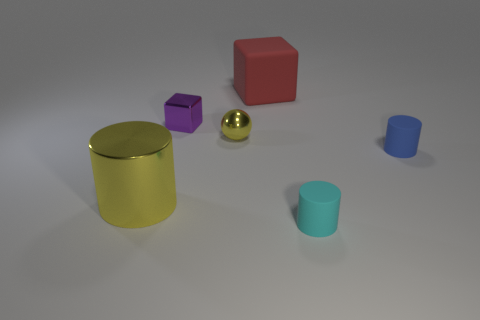Do the tiny yellow thing and the matte thing that is behind the blue rubber cylinder have the same shape?
Make the answer very short. No. How many things are both behind the shiny sphere and on the right side of the yellow ball?
Make the answer very short. 1. There is a yellow thing that is the same shape as the cyan rubber thing; what is it made of?
Give a very brief answer. Metal. There is a rubber cylinder in front of the tiny matte thing right of the cyan matte cylinder; what is its size?
Keep it short and to the point. Small. Are any tiny red cylinders visible?
Offer a terse response. No. What material is the small thing that is behind the cyan rubber cylinder and on the right side of the yellow sphere?
Offer a very short reply. Rubber. Is the number of small blue rubber objects on the left side of the small block greater than the number of big cubes on the left side of the red rubber object?
Your answer should be compact. No. Are there any blue matte objects of the same size as the red thing?
Provide a succinct answer. No. There is a yellow metallic object in front of the matte cylinder behind the tiny cylinder that is on the left side of the tiny blue thing; how big is it?
Your response must be concise. Large. The tiny metallic block has what color?
Offer a terse response. Purple. 